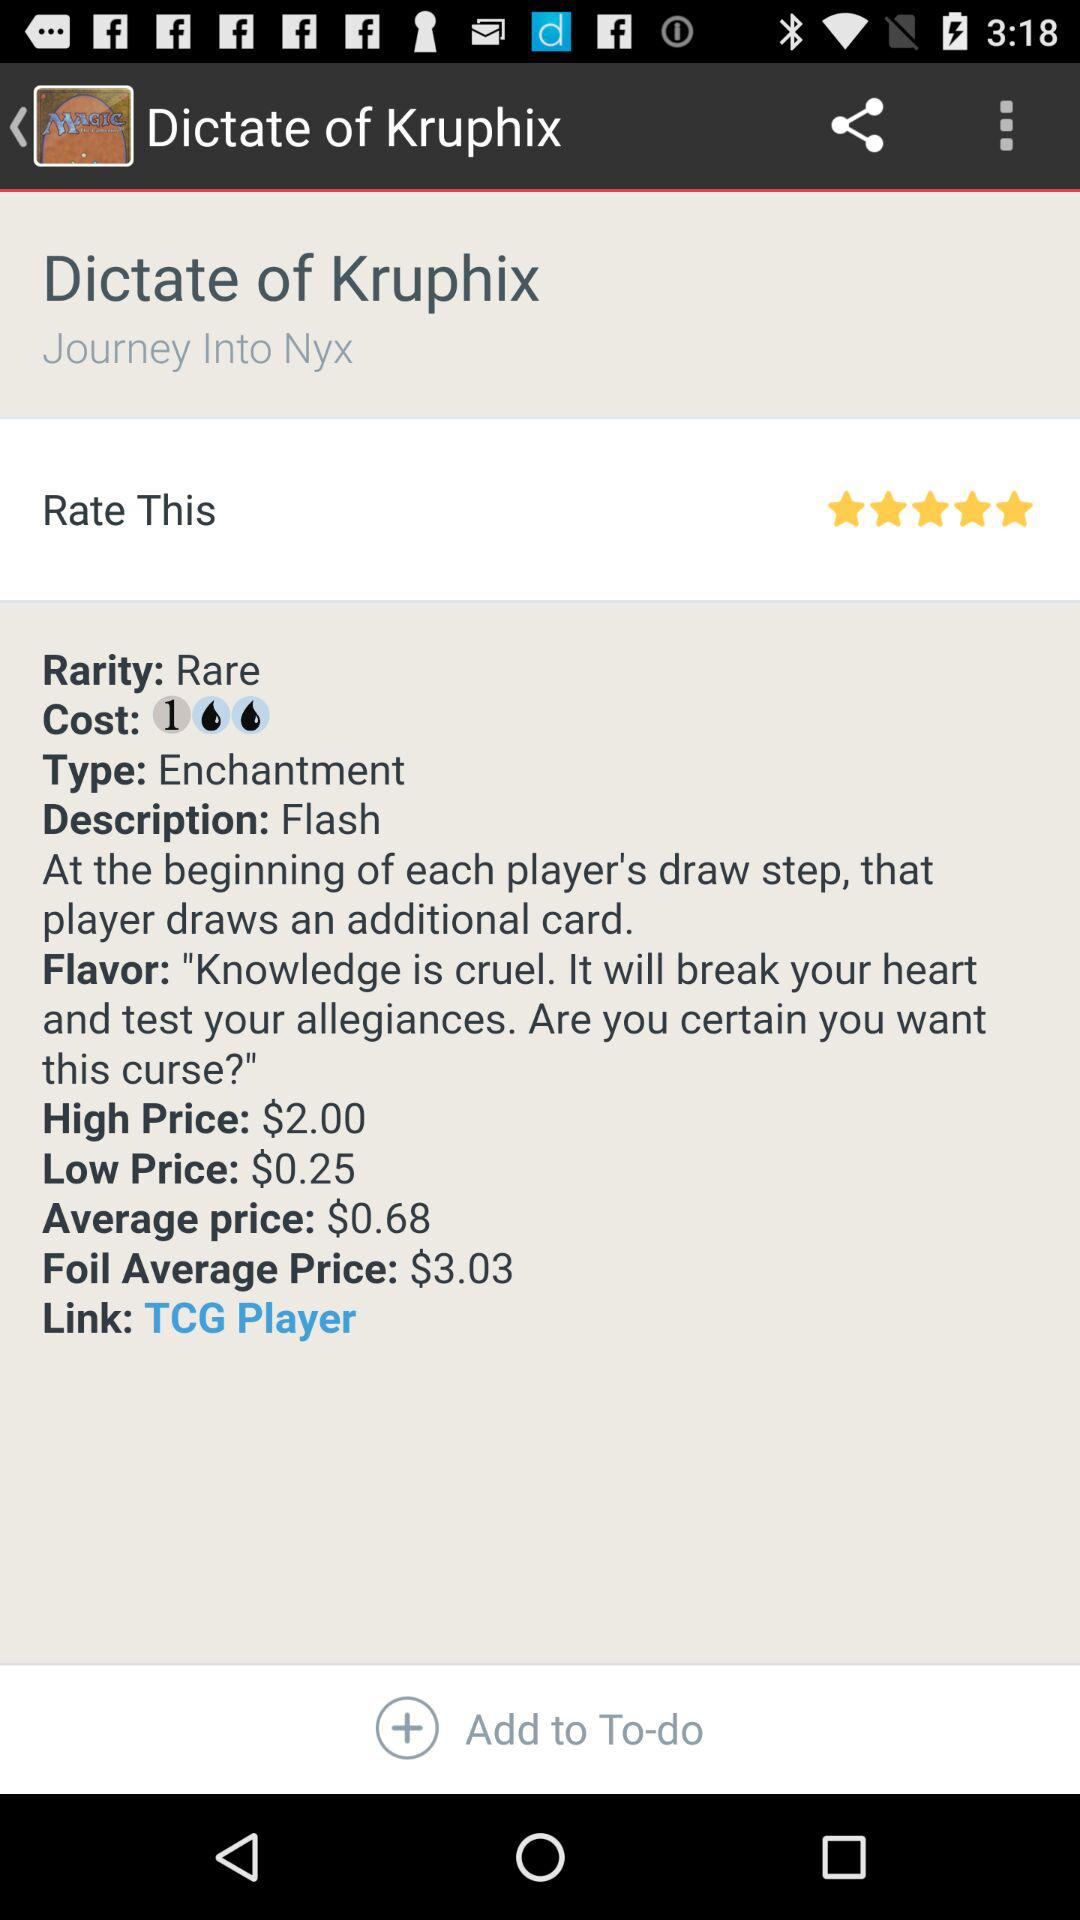What is the average price? The average price is $0.68. 